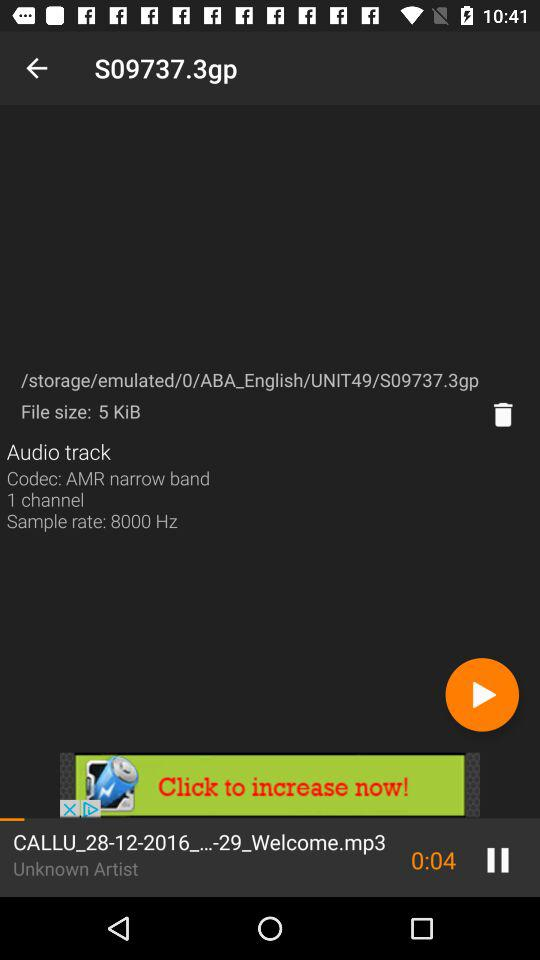What is the sample rate of an audio track? The sample rate of an audio track is 8000 Hz. 